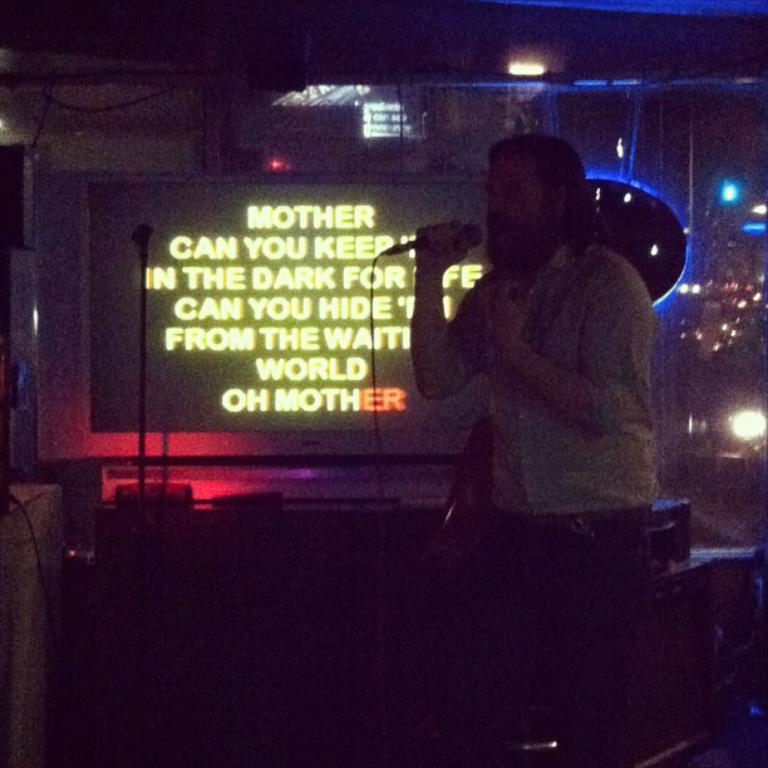What is the man in the image doing? The man is singing in the image. What object is the man holding while singing? The man is holding a microphone. Where is the man performing? The man is on a stage. What is present behind the man on the stage? There is a screen behind the man. What can be seen on the right side of the image? There are lights on the right side of the image. What type of plot is the man trying to resolve in the image? There is no plot present in the image; it is a man singing on a stage. Can you tell me how many fowl are visible in the image? There are no fowl present in the image. 